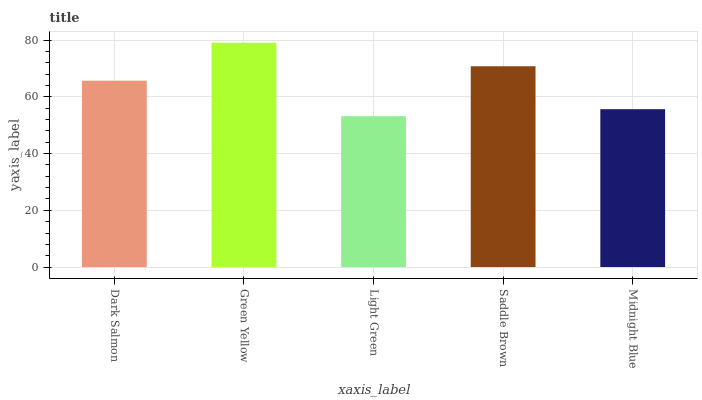Is Light Green the minimum?
Answer yes or no. Yes. Is Green Yellow the maximum?
Answer yes or no. Yes. Is Green Yellow the minimum?
Answer yes or no. No. Is Light Green the maximum?
Answer yes or no. No. Is Green Yellow greater than Light Green?
Answer yes or no. Yes. Is Light Green less than Green Yellow?
Answer yes or no. Yes. Is Light Green greater than Green Yellow?
Answer yes or no. No. Is Green Yellow less than Light Green?
Answer yes or no. No. Is Dark Salmon the high median?
Answer yes or no. Yes. Is Dark Salmon the low median?
Answer yes or no. Yes. Is Light Green the high median?
Answer yes or no. No. Is Green Yellow the low median?
Answer yes or no. No. 